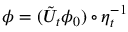<formula> <loc_0><loc_0><loc_500><loc_500>\phi = ( \tilde { U } _ { t } \phi _ { 0 } ) \circ \eta _ { t } ^ { - 1 }</formula> 